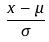Convert formula to latex. <formula><loc_0><loc_0><loc_500><loc_500>\frac { x - \mu } { \sigma }</formula> 